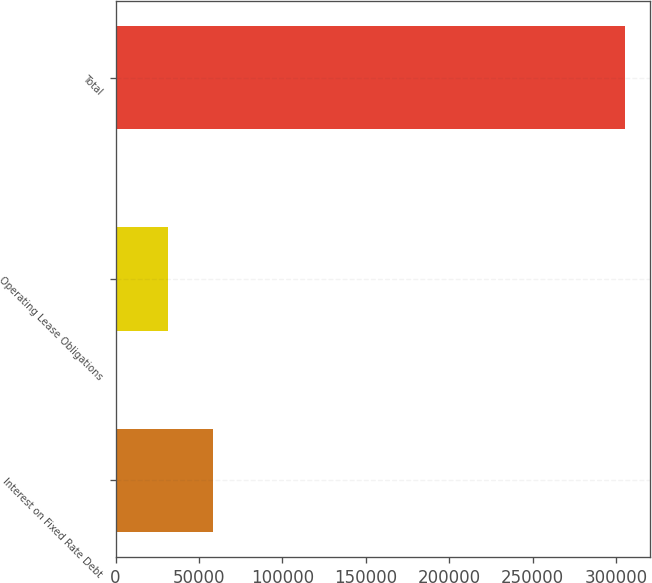Convert chart to OTSL. <chart><loc_0><loc_0><loc_500><loc_500><bar_chart><fcel>Interest on Fixed Rate Debt<fcel>Operating Lease Obligations<fcel>Total<nl><fcel>58571.5<fcel>31174<fcel>305149<nl></chart> 